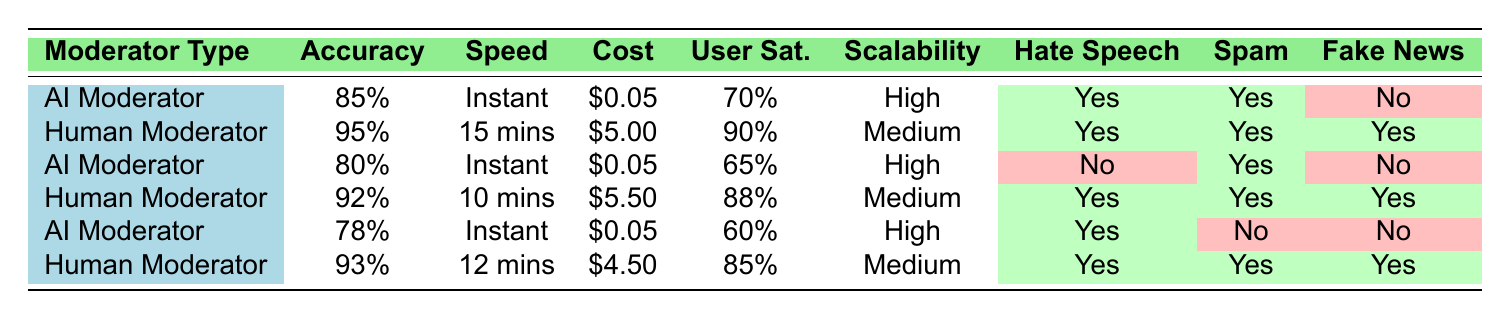What is the accuracy of the AI Moderator? From the table, the accuracy of the AI Moderator is listed as 85% in the first row.
Answer: 85% How long does it take for a Human Moderator to review content? The speed of moderation for the Human Moderator is shown as 15 mins in the second row.
Answer: 15 mins Which type of moderator has a higher user satisfaction rating, AI or Human? The Human Moderator has a user satisfaction rating of 90%, while the AI Moderator has a rating of 70%. Hence, the Human Moderator has a higher rating.
Answer: Human Moderator What is the average cost per review for the AI Moderators? The costs for the AI Moderators are $0.05, $0.05, and $0.05. To find the average, sum them up: 0.05 + 0.05 + 0.05 = 0.15, then divide by 3 (number of AI Moderators): 0.15 / 3 = 0.05.
Answer: 0.05 Does the AI Moderator detect fake news? In the table, under "Detects Fake News," all instances of the AI Moderator show a "No," indicating that the AI Moderator does not detect fake news.
Answer: No What is the scalability rating of the Human Moderator with the highest accuracy? The Human Moderator with the highest accuracy (95%) is in the second row and has a scalability rating of "Medium."
Answer: Medium Among the types of moderators, which one is the fastest in terms of speed of moderation? Both AI Moderators provide "Instant" speed, which is faster than the Human Moderators that range from "10 mins" to "15 mins." That's why AI Moderators are the fastest.
Answer: AI Moderator What percentage of user satisfaction does the AI Moderator with 78% accuracy have? Referring to the row with 78% accuracy for AI Moderators, the user satisfaction rating listed is 60%.
Answer: 60% How many types of moderators detect hate speech? By reviewing the table, all instances of both AI and Human Moderators detect hate speech, which accounts for 5 out of 6 rows. Therefore, both types detect hate speech.
Answer: Both types What is the difference in accuracy between the best and worst Human Moderator? The highest accuracy for a Human Moderator is 95%, and the lowest is 92%. The difference is calculated as 95 - 92 = 3.
Answer: 3 